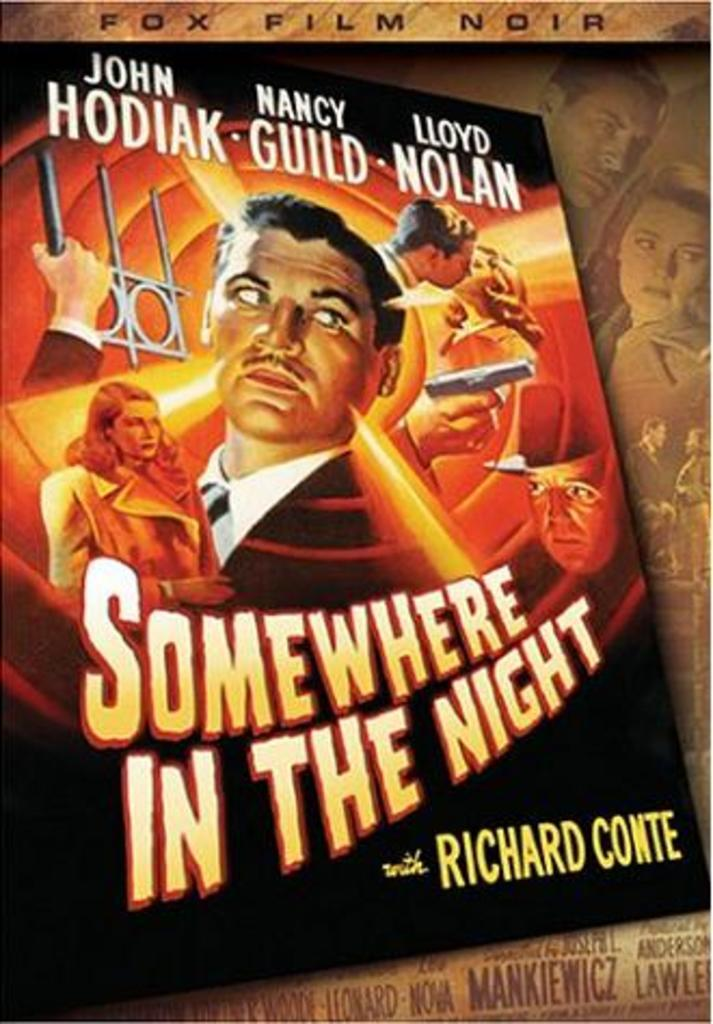<image>
Write a terse but informative summary of the picture. A poster with men and women on it for a movie called Somewhere In The Night. 